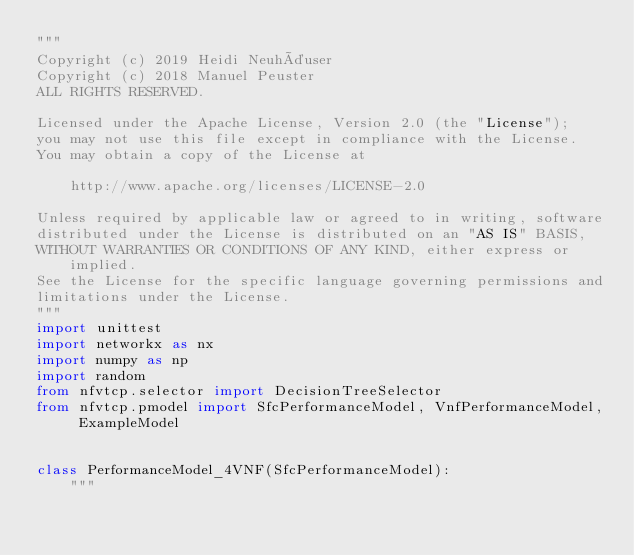<code> <loc_0><loc_0><loc_500><loc_500><_Python_>"""
Copyright (c) 2019 Heidi Neuhäuser
Copyright (c) 2018 Manuel Peuster
ALL RIGHTS RESERVED.

Licensed under the Apache License, Version 2.0 (the "License");
you may not use this file except in compliance with the License.
You may obtain a copy of the License at

    http://www.apache.org/licenses/LICENSE-2.0

Unless required by applicable law or agreed to in writing, software
distributed under the License is distributed on an "AS IS" BASIS,
WITHOUT WARRANTIES OR CONDITIONS OF ANY KIND, either express or implied.
See the License for the specific language governing permissions and
limitations under the License.
"""
import unittest
import networkx as nx
import numpy as np
import random
from nfvtcp.selector import DecisionTreeSelector
from nfvtcp.pmodel import SfcPerformanceModel, VnfPerformanceModel, ExampleModel


class PerformanceModel_4VNF(SfcPerformanceModel):
    """</code> 